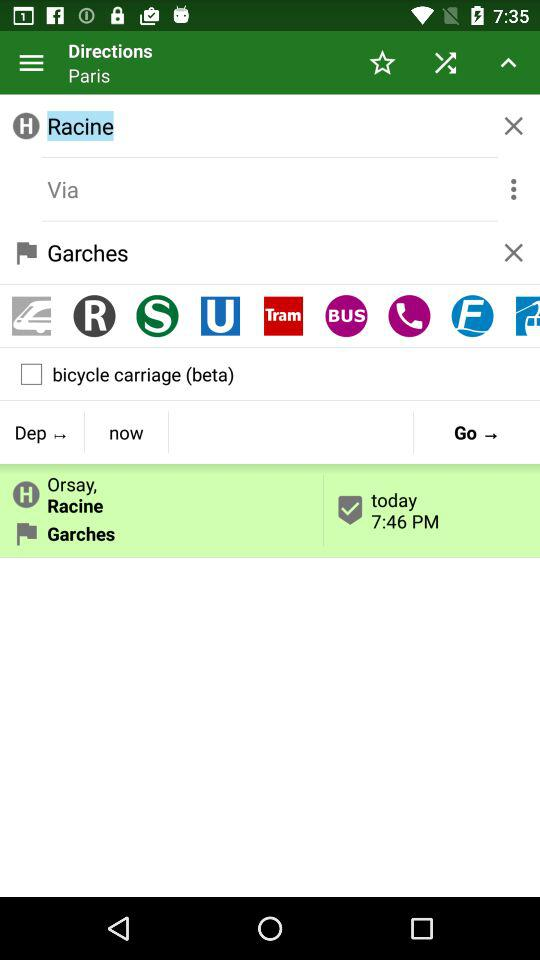What is the displayed time on the screen? The displayed time is 7:46 PM. 